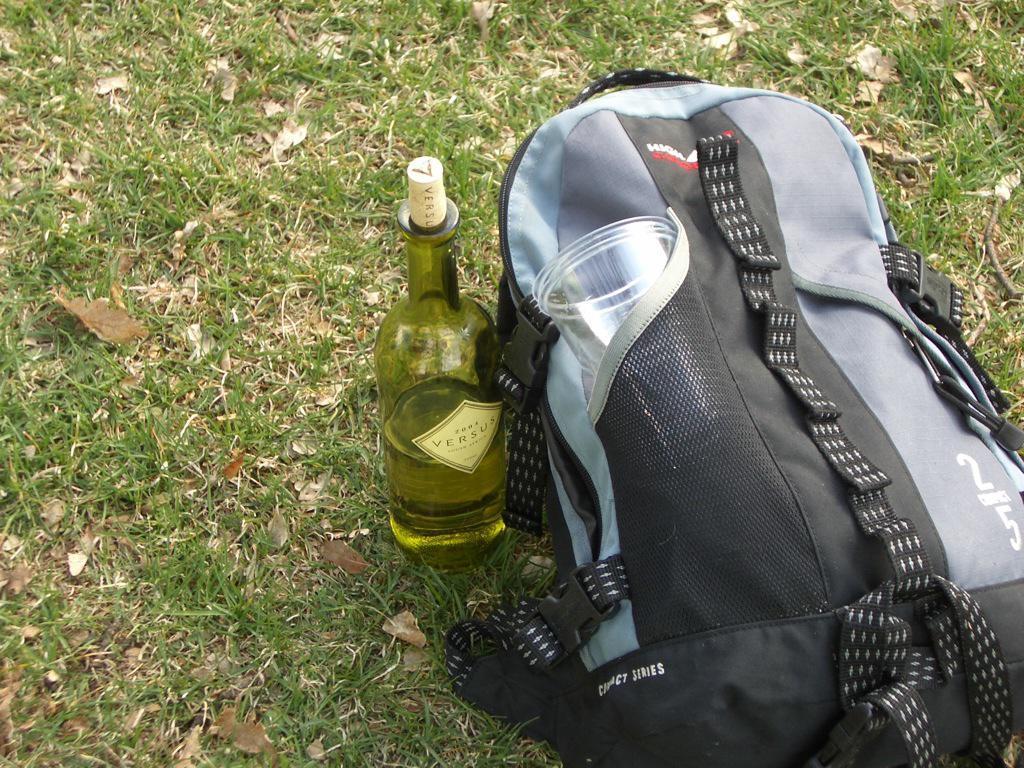How would you summarize this image in a sentence or two? In this picture there is a bag on the floor and there is a bottle beside it, there are some trees around the area of the image. 